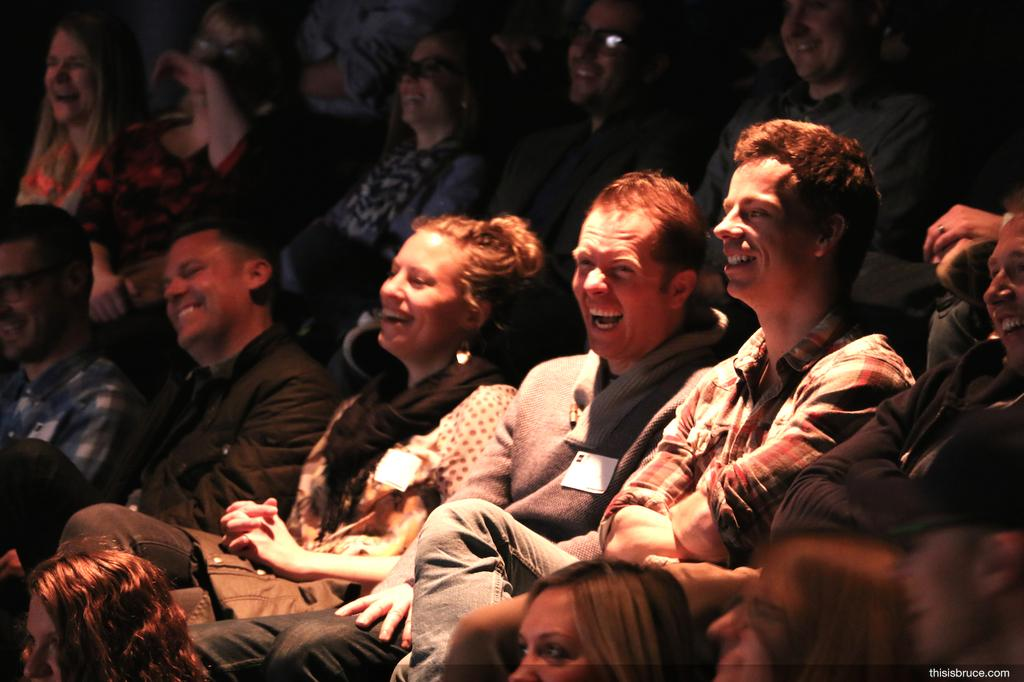What is the primary activity of the people in the image? The people in the image are sitting. Can you describe any objects present in the image? There are few cards visible in the image. What type of robin is perched on the cards in the image? There is no robin present in the image; it only features people sitting and a few cards. 